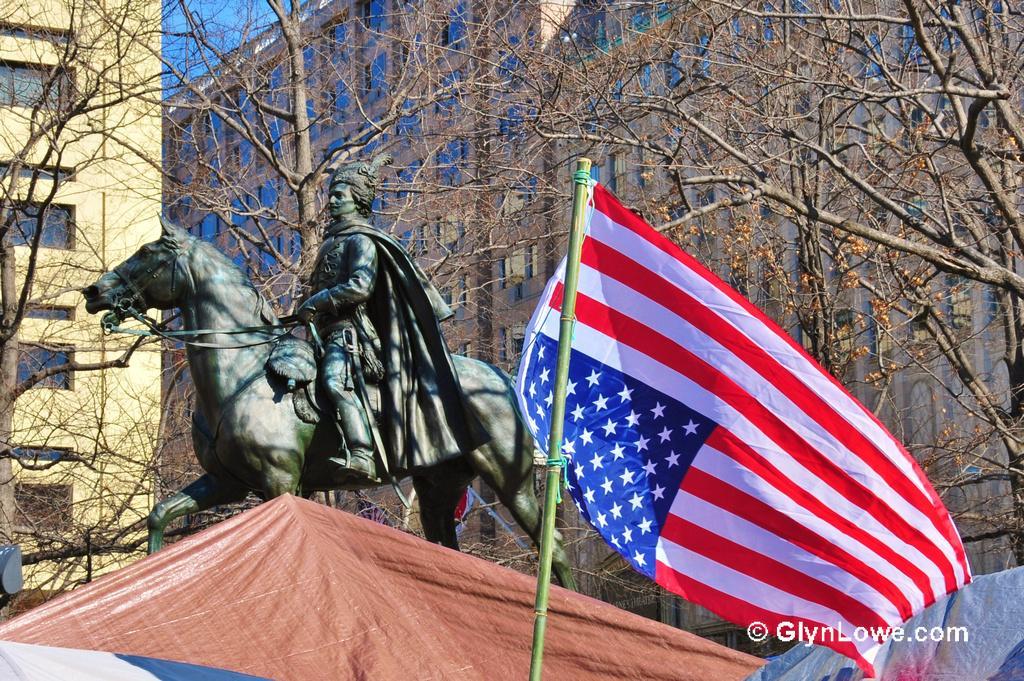In one or two sentences, can you explain what this image depicts? In this picture there is a statue of a person and a horse. Here it's a flag. There is a tree. On the background there is a building. On the top left there is a sky. Here it's a tent. 